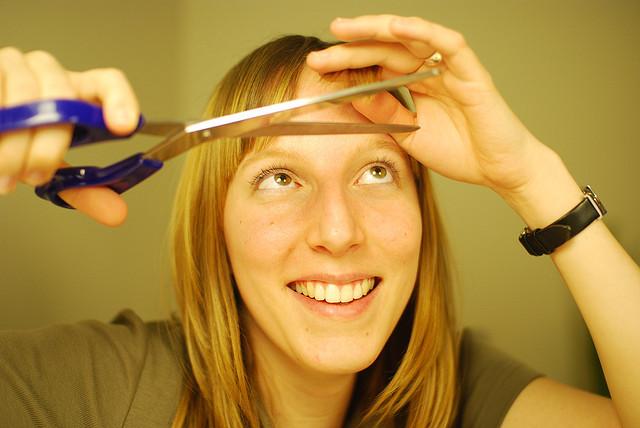Will this person cut off any black hair?
Give a very brief answer. No. Is she wearing a bracelet?
Keep it brief. No. Which way is the girl looking?
Be succinct. Up. 